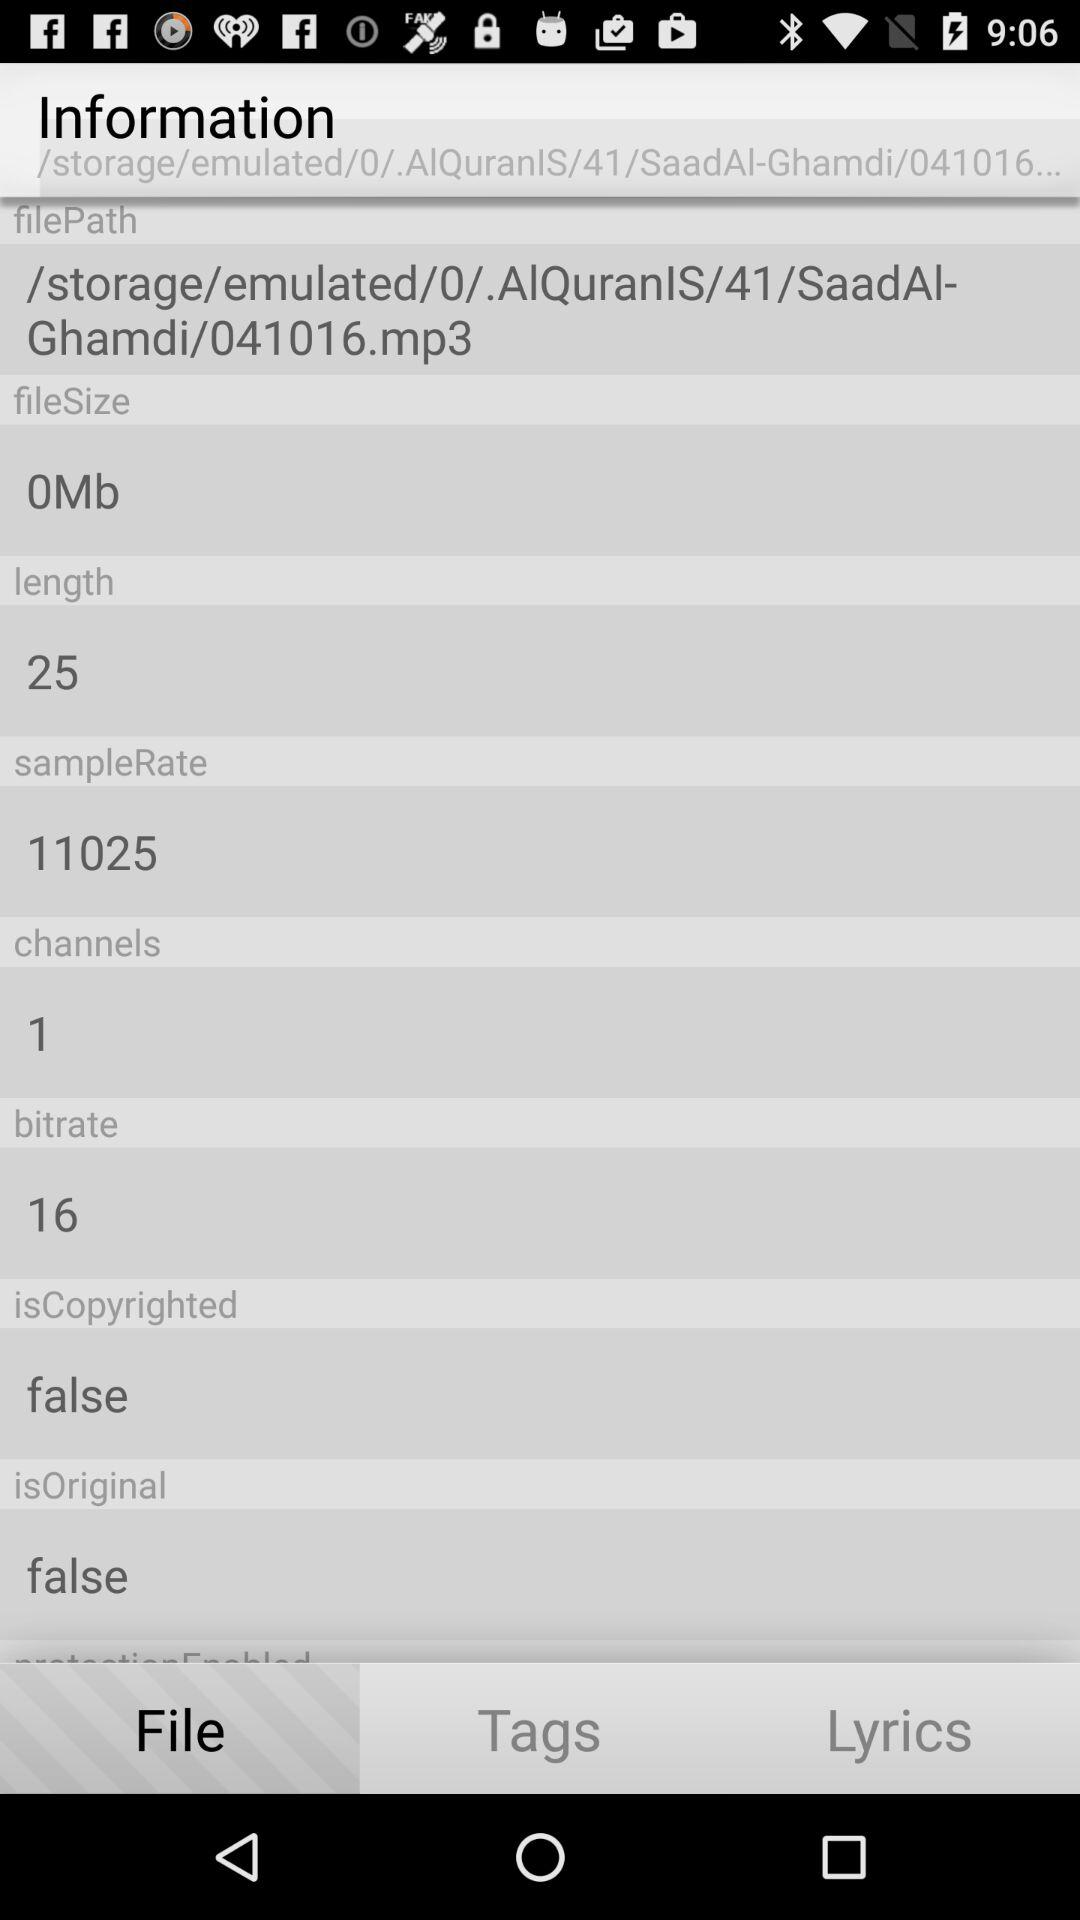What is the length of the audio file in seconds?
Answer the question using a single word or phrase. 25 